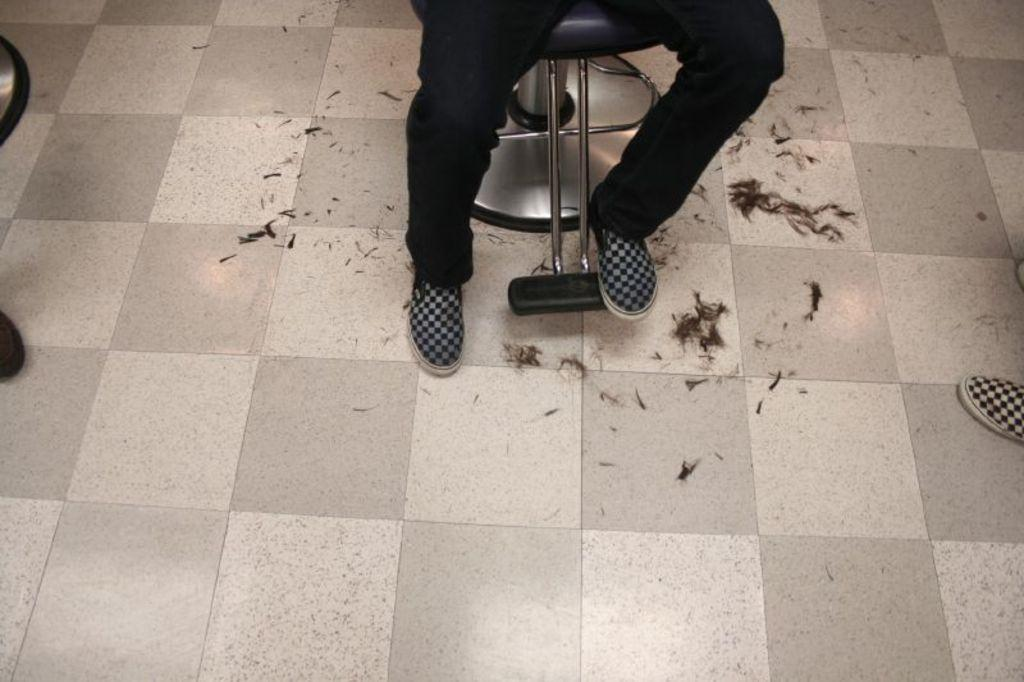What is placed on the chair in the image? There are two legs with shoes on a chair in the image. How many chairs are visible in the image? There are two chairs in the image. Can you describe the visible shoe in the image? There is one shoe visible in the image. What is present on the floor in the image? There is hair on the floor in the image. What type of writing can be seen on the floor in the image? There is no writing present on the floor in the image; it only shows hair. 